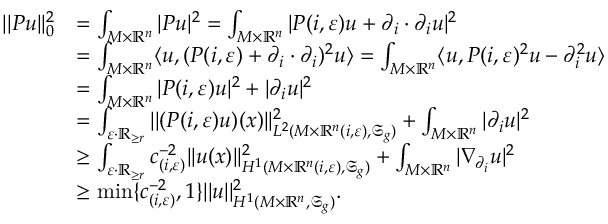<formula> <loc_0><loc_0><loc_500><loc_500>\begin{array} { r l } { | | P u | | _ { 0 } ^ { 2 } } & { = \int _ { M \times \mathbb { R } ^ { n } } | P u | ^ { 2 } = \int _ { M \times \mathbb { R } ^ { n } } | P ( i , \varepsilon ) u + \partial _ { i } \cdot \partial _ { i } u | ^ { 2 } } \\ & { = \int _ { M \times \mathbb { R } ^ { n } } \langle u , ( P ( i , \varepsilon ) + \partial _ { i } \cdot \partial _ { i } ) ^ { 2 } u \rangle = \int _ { M \times \mathbb { R } ^ { n } } \langle u , P ( i , \varepsilon ) ^ { 2 } u - \partial _ { i } ^ { 2 } u \rangle } \\ & { = \int _ { M \times \mathbb { R } ^ { n } } | P ( i , \varepsilon ) u | ^ { 2 } + | \partial _ { i } u | ^ { 2 } } \\ & { = \int _ { \varepsilon \cdot \mathbb { R } _ { \geq r } } | | ( P ( i , \varepsilon ) u ) ( x ) | | _ { L ^ { 2 } ( M \times \mathbb { R } ^ { n } ( i , \varepsilon ) , \mathfrak { S } _ { g } ) } ^ { 2 } + \int _ { M \times \mathbb { R } ^ { n } } | \partial _ { i } u | ^ { 2 } } \\ & { \geq \int _ { \varepsilon \cdot \mathbb { R } _ { \geq r } } c _ { ( i , \varepsilon ) } ^ { - 2 } | | u ( x ) | | _ { H ^ { 1 } ( M \times \mathbb { R } ^ { n } ( i , \varepsilon ) , \mathfrak { S } _ { g } ) } ^ { 2 } + \int _ { M \times \mathbb { R } ^ { n } } | \nabla _ { \partial _ { i } } u | ^ { 2 } } \\ & { \geq \min \{ c _ { ( i , \varepsilon ) } ^ { - 2 } , 1 \} | | u | | _ { H ^ { 1 } ( M \times \mathbb { R } ^ { n } , \mathfrak { S } _ { g } ) } ^ { 2 } . } \end{array}</formula> 